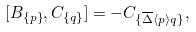Convert formula to latex. <formula><loc_0><loc_0><loc_500><loc_500>[ B _ { \{ p \} } , C _ { \{ q \} } ] = - C _ { \{ \overline { \Delta } \langle p \rangle q \} } ,</formula> 